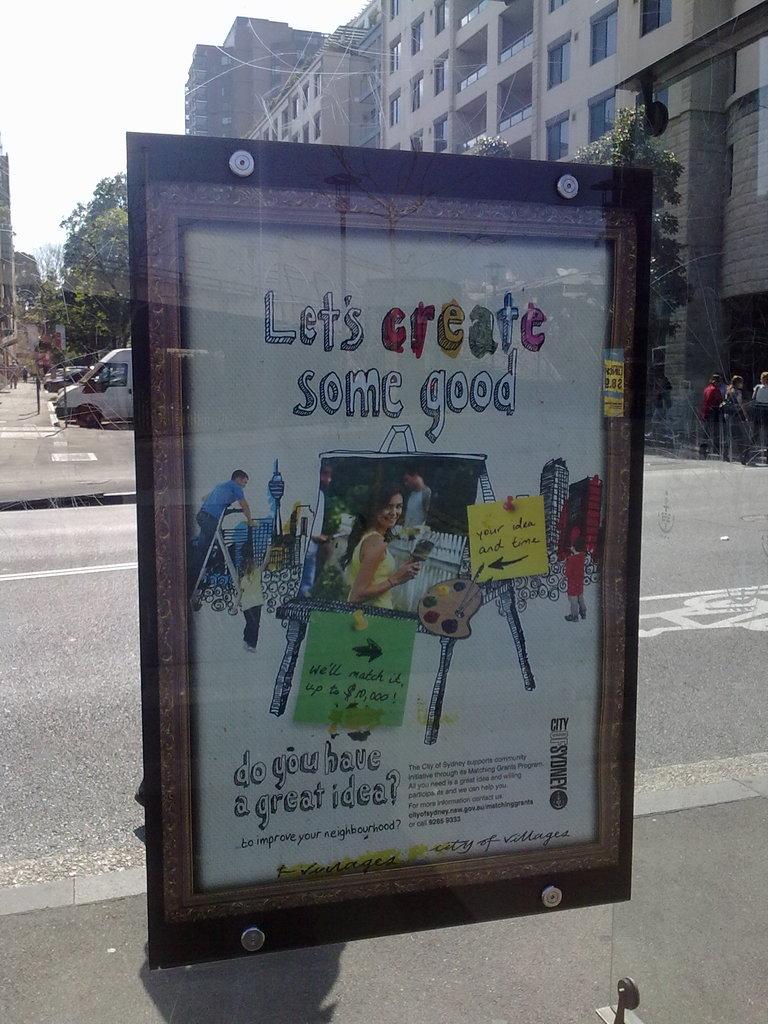What should we create?
Provide a short and direct response. Some good. What city is this from?
Your answer should be very brief. Sydney. 